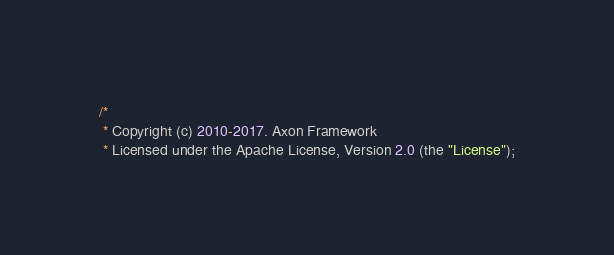<code> <loc_0><loc_0><loc_500><loc_500><_Java_>/*
 * Copyright (c) 2010-2017. Axon Framework
 * Licensed under the Apache License, Version 2.0 (the "License");</code> 